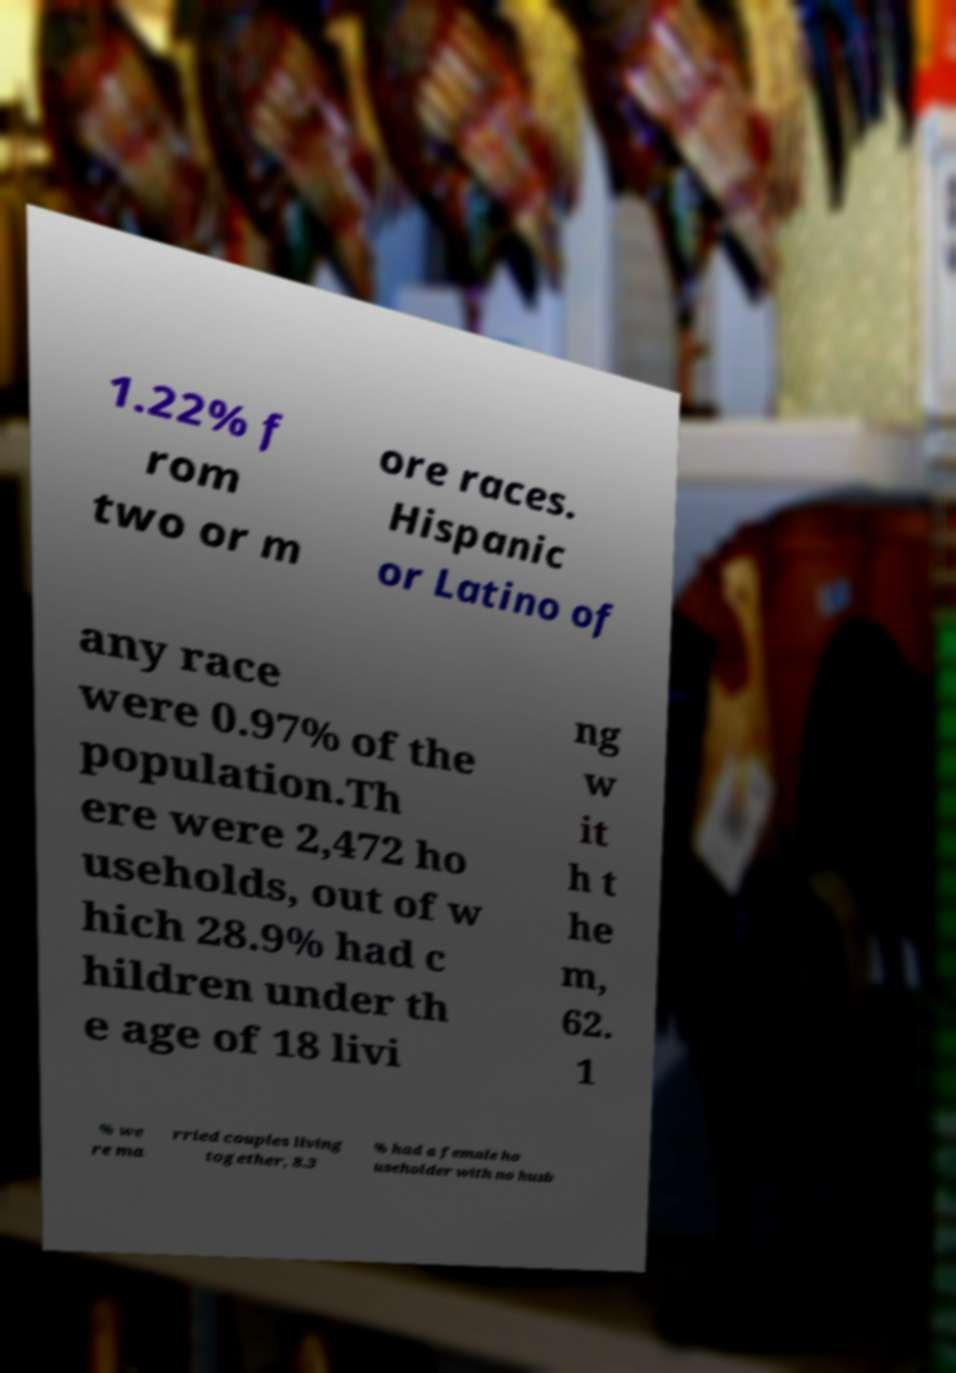There's text embedded in this image that I need extracted. Can you transcribe it verbatim? 1.22% f rom two or m ore races. Hispanic or Latino of any race were 0.97% of the population.Th ere were 2,472 ho useholds, out of w hich 28.9% had c hildren under th e age of 18 livi ng w it h t he m, 62. 1 % we re ma rried couples living together, 8.3 % had a female ho useholder with no husb 